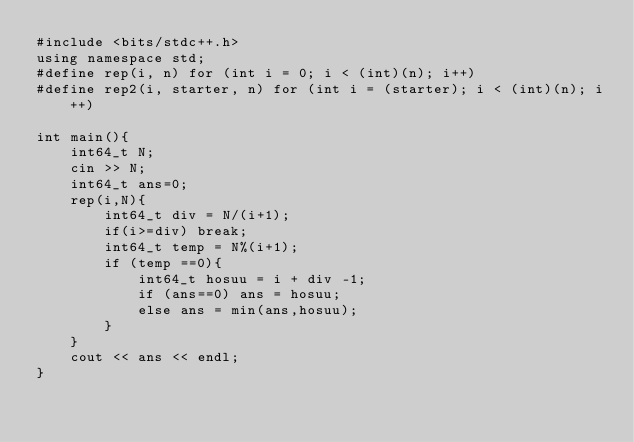<code> <loc_0><loc_0><loc_500><loc_500><_C++_>#include <bits/stdc++.h>
using namespace std;
#define rep(i, n) for (int i = 0; i < (int)(n); i++)
#define rep2(i, starter, n) for (int i = (starter); i < (int)(n); i++)

int main(){
    int64_t N;
    cin >> N;
    int64_t ans=0;
    rep(i,N){
        int64_t div = N/(i+1);
        if(i>=div) break;
        int64_t temp = N%(i+1);
        if (temp ==0){
            int64_t hosuu = i + div -1;
            if (ans==0) ans = hosuu;
            else ans = min(ans,hosuu);
        } 
    }
    cout << ans << endl;
}</code> 